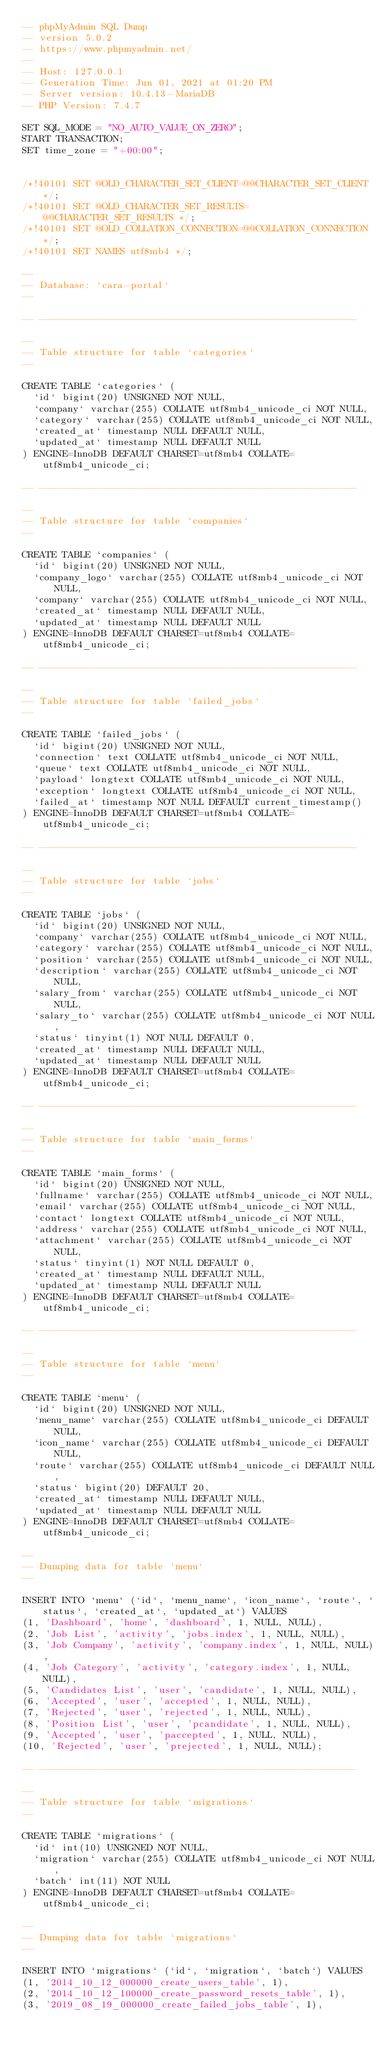Convert code to text. <code><loc_0><loc_0><loc_500><loc_500><_SQL_>-- phpMyAdmin SQL Dump
-- version 5.0.2
-- https://www.phpmyadmin.net/
--
-- Host: 127.0.0.1
-- Generation Time: Jun 01, 2021 at 01:20 PM
-- Server version: 10.4.13-MariaDB
-- PHP Version: 7.4.7

SET SQL_MODE = "NO_AUTO_VALUE_ON_ZERO";
START TRANSACTION;
SET time_zone = "+00:00";


/*!40101 SET @OLD_CHARACTER_SET_CLIENT=@@CHARACTER_SET_CLIENT */;
/*!40101 SET @OLD_CHARACTER_SET_RESULTS=@@CHARACTER_SET_RESULTS */;
/*!40101 SET @OLD_COLLATION_CONNECTION=@@COLLATION_CONNECTION */;
/*!40101 SET NAMES utf8mb4 */;

--
-- Database: `cara-portal`
--

-- --------------------------------------------------------

--
-- Table structure for table `categories`
--

CREATE TABLE `categories` (
  `id` bigint(20) UNSIGNED NOT NULL,
  `company` varchar(255) COLLATE utf8mb4_unicode_ci NOT NULL,
  `category` varchar(255) COLLATE utf8mb4_unicode_ci NOT NULL,
  `created_at` timestamp NULL DEFAULT NULL,
  `updated_at` timestamp NULL DEFAULT NULL
) ENGINE=InnoDB DEFAULT CHARSET=utf8mb4 COLLATE=utf8mb4_unicode_ci;

-- --------------------------------------------------------

--
-- Table structure for table `companies`
--

CREATE TABLE `companies` (
  `id` bigint(20) UNSIGNED NOT NULL,
  `company_logo` varchar(255) COLLATE utf8mb4_unicode_ci NOT NULL,
  `company` varchar(255) COLLATE utf8mb4_unicode_ci NOT NULL,
  `created_at` timestamp NULL DEFAULT NULL,
  `updated_at` timestamp NULL DEFAULT NULL
) ENGINE=InnoDB DEFAULT CHARSET=utf8mb4 COLLATE=utf8mb4_unicode_ci;

-- --------------------------------------------------------

--
-- Table structure for table `failed_jobs`
--

CREATE TABLE `failed_jobs` (
  `id` bigint(20) UNSIGNED NOT NULL,
  `connection` text COLLATE utf8mb4_unicode_ci NOT NULL,
  `queue` text COLLATE utf8mb4_unicode_ci NOT NULL,
  `payload` longtext COLLATE utf8mb4_unicode_ci NOT NULL,
  `exception` longtext COLLATE utf8mb4_unicode_ci NOT NULL,
  `failed_at` timestamp NOT NULL DEFAULT current_timestamp()
) ENGINE=InnoDB DEFAULT CHARSET=utf8mb4 COLLATE=utf8mb4_unicode_ci;

-- --------------------------------------------------------

--
-- Table structure for table `jobs`
--

CREATE TABLE `jobs` (
  `id` bigint(20) UNSIGNED NOT NULL,
  `company` varchar(255) COLLATE utf8mb4_unicode_ci NOT NULL,
  `category` varchar(255) COLLATE utf8mb4_unicode_ci NOT NULL,
  `position` varchar(255) COLLATE utf8mb4_unicode_ci NOT NULL,
  `description` varchar(255) COLLATE utf8mb4_unicode_ci NOT NULL,
  `salary_from` varchar(255) COLLATE utf8mb4_unicode_ci NOT NULL,
  `salary_to` varchar(255) COLLATE utf8mb4_unicode_ci NOT NULL,
  `status` tinyint(1) NOT NULL DEFAULT 0,
  `created_at` timestamp NULL DEFAULT NULL,
  `updated_at` timestamp NULL DEFAULT NULL
) ENGINE=InnoDB DEFAULT CHARSET=utf8mb4 COLLATE=utf8mb4_unicode_ci;

-- --------------------------------------------------------

--
-- Table structure for table `main_forms`
--

CREATE TABLE `main_forms` (
  `id` bigint(20) UNSIGNED NOT NULL,
  `fullname` varchar(255) COLLATE utf8mb4_unicode_ci NOT NULL,
  `email` varchar(255) COLLATE utf8mb4_unicode_ci NOT NULL,
  `contact` longtext COLLATE utf8mb4_unicode_ci NOT NULL,
  `address` varchar(255) COLLATE utf8mb4_unicode_ci NOT NULL,
  `attachment` varchar(255) COLLATE utf8mb4_unicode_ci NOT NULL,
  `status` tinyint(1) NOT NULL DEFAULT 0,
  `created_at` timestamp NULL DEFAULT NULL,
  `updated_at` timestamp NULL DEFAULT NULL
) ENGINE=InnoDB DEFAULT CHARSET=utf8mb4 COLLATE=utf8mb4_unicode_ci;

-- --------------------------------------------------------

--
-- Table structure for table `menu`
--

CREATE TABLE `menu` (
  `id` bigint(20) UNSIGNED NOT NULL,
  `menu_name` varchar(255) COLLATE utf8mb4_unicode_ci DEFAULT NULL,
  `icon_name` varchar(255) COLLATE utf8mb4_unicode_ci DEFAULT NULL,
  `route` varchar(255) COLLATE utf8mb4_unicode_ci DEFAULT NULL,
  `status` bigint(20) DEFAULT 20,
  `created_at` timestamp NULL DEFAULT NULL,
  `updated_at` timestamp NULL DEFAULT NULL
) ENGINE=InnoDB DEFAULT CHARSET=utf8mb4 COLLATE=utf8mb4_unicode_ci;

--
-- Dumping data for table `menu`
--

INSERT INTO `menu` (`id`, `menu_name`, `icon_name`, `route`, `status`, `created_at`, `updated_at`) VALUES
(1, 'Dashboard', 'home', 'dashboard', 1, NULL, NULL),
(2, 'Job List', 'activity', 'jobs.index', 1, NULL, NULL),
(3, 'Job Company', 'activity', 'company.index', 1, NULL, NULL),
(4, 'Job Category', 'activity', 'category.index', 1, NULL, NULL),
(5, 'Candidates List', 'user', 'candidate', 1, NULL, NULL),
(6, 'Accepted', 'user', 'accepted', 1, NULL, NULL),
(7, 'Rejected', 'user', 'rejected', 1, NULL, NULL),
(8, 'Position List', 'user', 'pcandidate', 1, NULL, NULL),
(9, 'Accepted', 'user', 'paccepted', 1, NULL, NULL),
(10, 'Rejected', 'user', 'prejected', 1, NULL, NULL);

-- --------------------------------------------------------

--
-- Table structure for table `migrations`
--

CREATE TABLE `migrations` (
  `id` int(10) UNSIGNED NOT NULL,
  `migration` varchar(255) COLLATE utf8mb4_unicode_ci NOT NULL,
  `batch` int(11) NOT NULL
) ENGINE=InnoDB DEFAULT CHARSET=utf8mb4 COLLATE=utf8mb4_unicode_ci;

--
-- Dumping data for table `migrations`
--

INSERT INTO `migrations` (`id`, `migration`, `batch`) VALUES
(1, '2014_10_12_000000_create_users_table', 1),
(2, '2014_10_12_100000_create_password_resets_table', 1),
(3, '2019_08_19_000000_create_failed_jobs_table', 1),</code> 